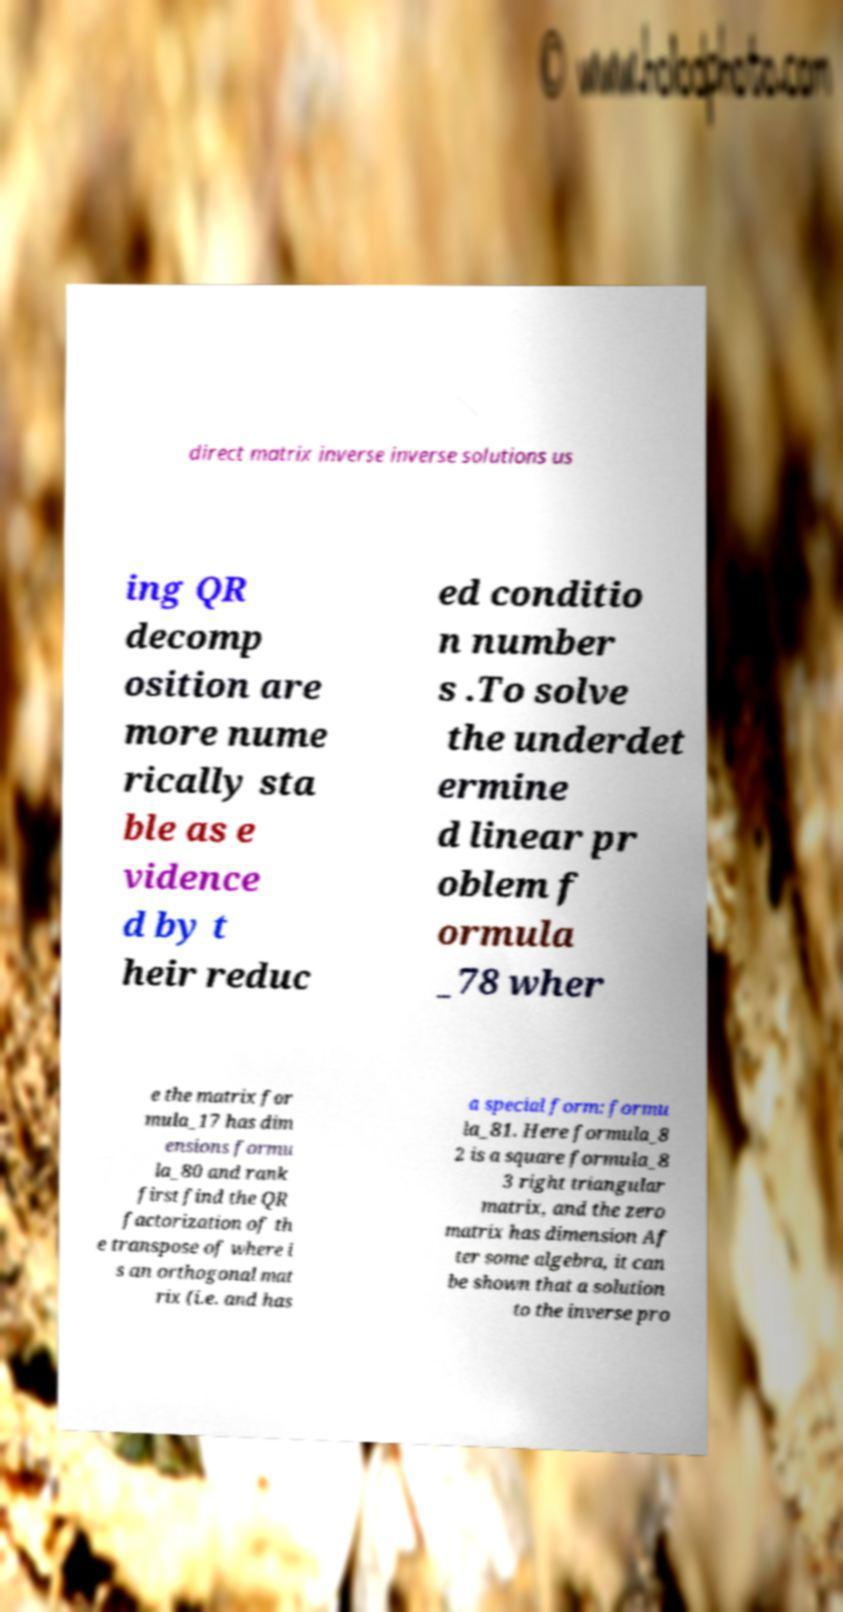Could you extract and type out the text from this image? direct matrix inverse inverse solutions us ing QR decomp osition are more nume rically sta ble as e vidence d by t heir reduc ed conditio n number s .To solve the underdet ermine d linear pr oblem f ormula _78 wher e the matrix for mula_17 has dim ensions formu la_80 and rank first find the QR factorization of th e transpose of where i s an orthogonal mat rix (i.e. and has a special form: formu la_81. Here formula_8 2 is a square formula_8 3 right triangular matrix, and the zero matrix has dimension Af ter some algebra, it can be shown that a solution to the inverse pro 